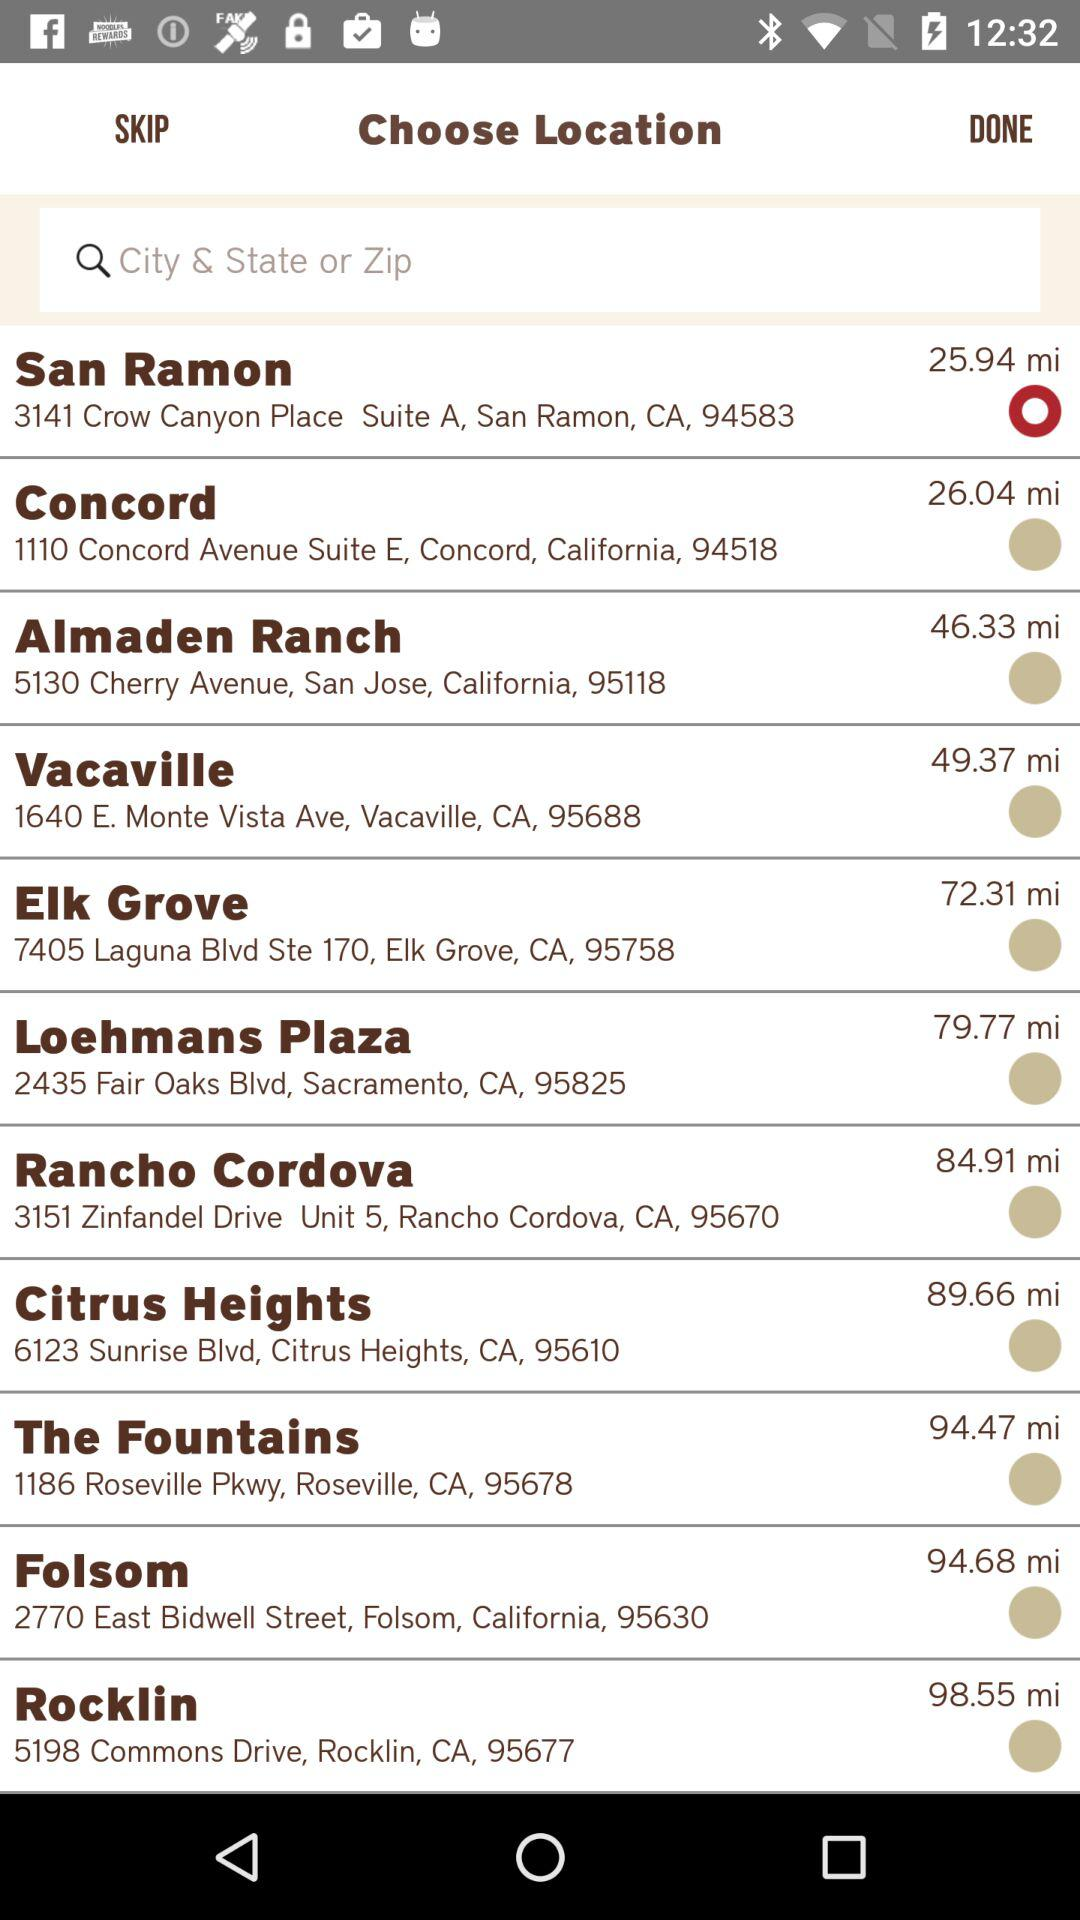What is the Zip code of Folsom? The Zip code of Folsom is 95630. 